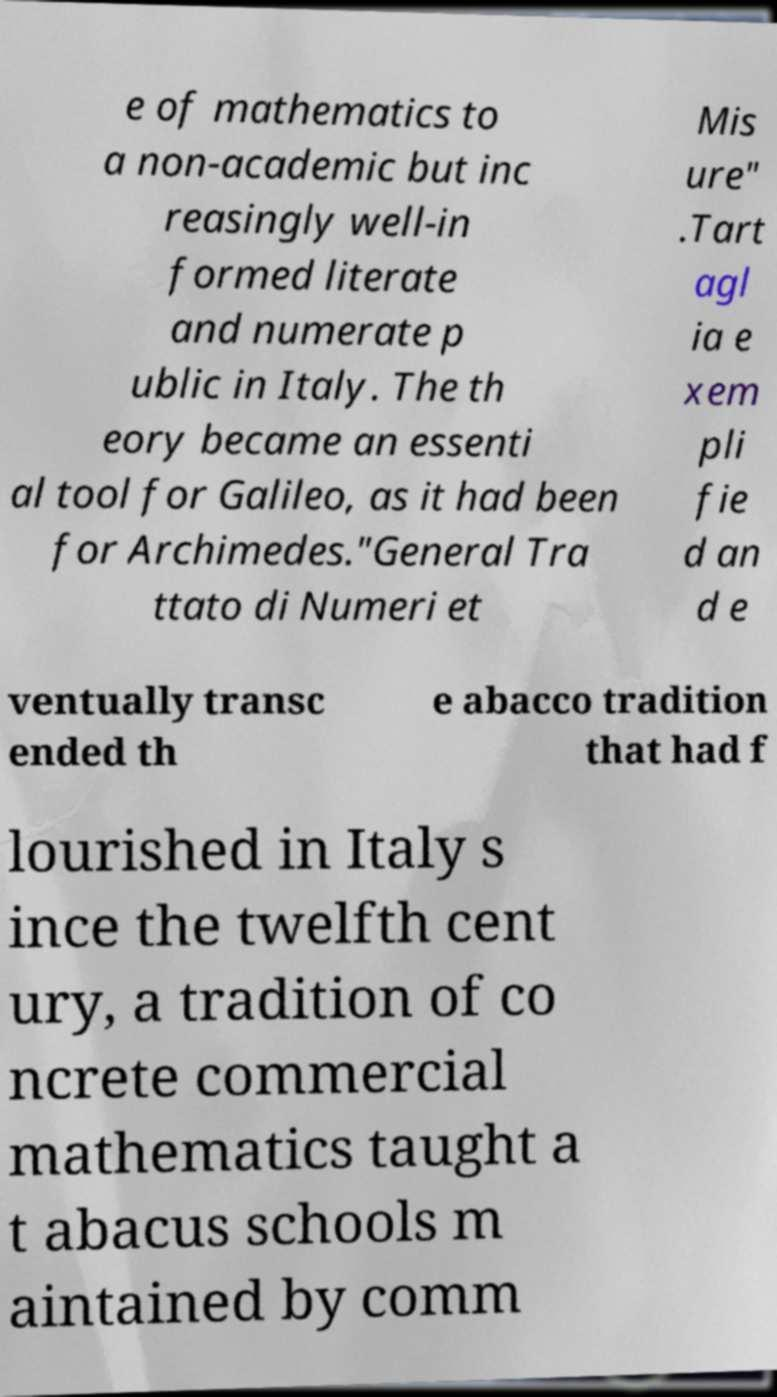Please identify and transcribe the text found in this image. e of mathematics to a non-academic but inc reasingly well-in formed literate and numerate p ublic in Italy. The th eory became an essenti al tool for Galileo, as it had been for Archimedes."General Tra ttato di Numeri et Mis ure" .Tart agl ia e xem pli fie d an d e ventually transc ended th e abacco tradition that had f lourished in Italy s ince the twelfth cent ury, a tradition of co ncrete commercial mathematics taught a t abacus schools m aintained by comm 